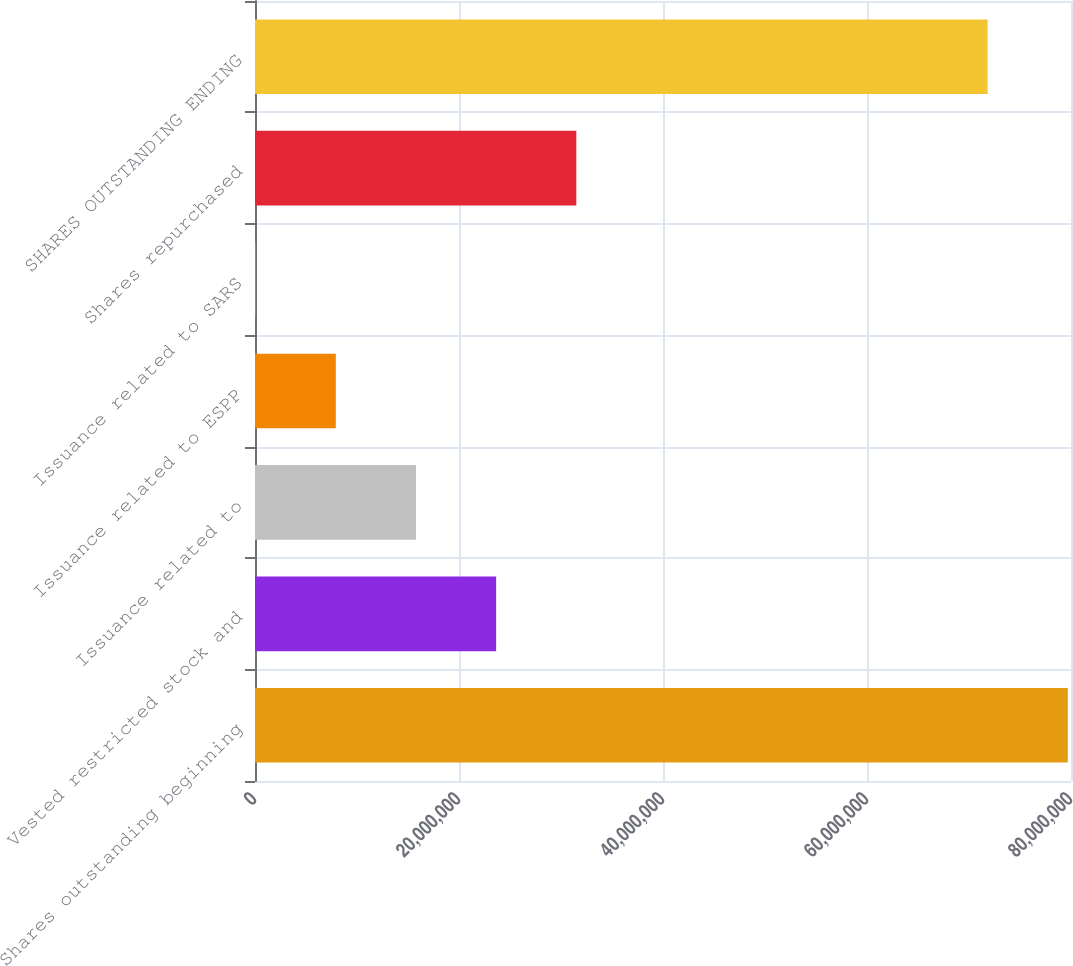Convert chart to OTSL. <chart><loc_0><loc_0><loc_500><loc_500><bar_chart><fcel>Shares outstanding beginning<fcel>Vested restricted stock and<fcel>Issuance related to<fcel>Issuance related to ESPP<fcel>Issuance related to SARS<fcel>Shares repurchased<fcel>SHARES OUTSTANDING ENDING<nl><fcel>7.96885e+07<fcel>2.3642e+07<fcel>1.57817e+07<fcel>7.92137e+06<fcel>61070<fcel>3.15023e+07<fcel>7.18282e+07<nl></chart> 